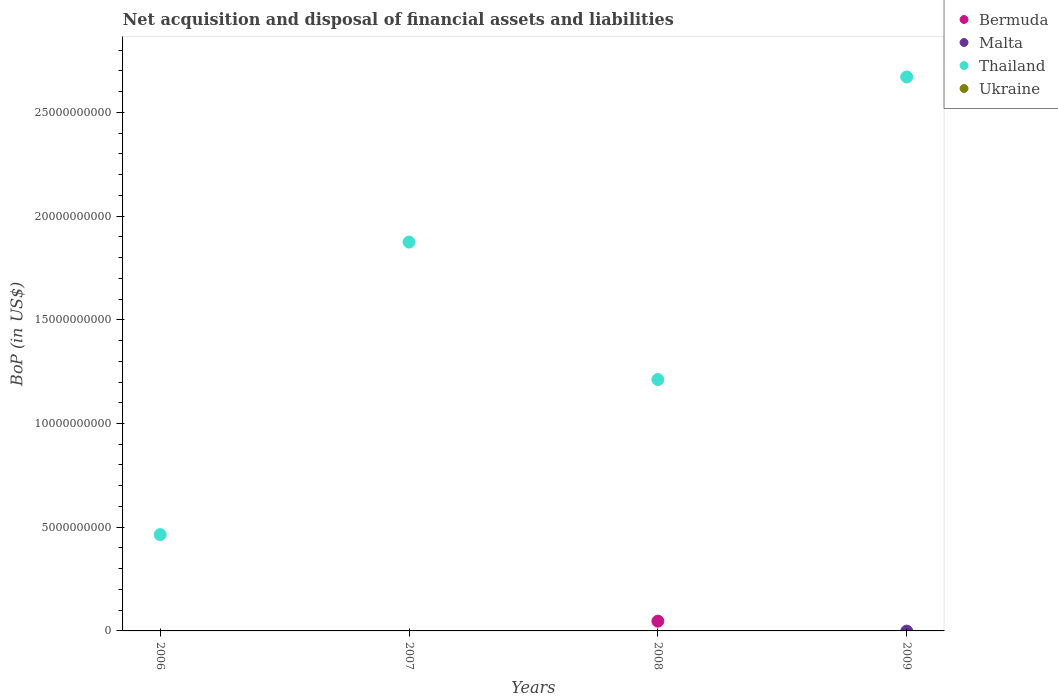How many different coloured dotlines are there?
Give a very brief answer. 2. What is the Balance of Payments in Ukraine in 2007?
Offer a very short reply. 0. Across all years, what is the maximum Balance of Payments in Bermuda?
Your response must be concise. 4.69e+08. Across all years, what is the minimum Balance of Payments in Ukraine?
Keep it short and to the point. 0. In which year was the Balance of Payments in Thailand maximum?
Provide a succinct answer. 2009. What is the difference between the Balance of Payments in Thailand in 2006 and that in 2009?
Your response must be concise. -2.21e+1. What is the difference between the Balance of Payments in Ukraine in 2006 and the Balance of Payments in Bermuda in 2008?
Your answer should be compact. -4.69e+08. In how many years, is the Balance of Payments in Ukraine greater than 21000000000 US$?
Provide a short and direct response. 0. What is the difference between the highest and the lowest Balance of Payments in Bermuda?
Keep it short and to the point. 4.69e+08. Is the sum of the Balance of Payments in Thailand in 2008 and 2009 greater than the maximum Balance of Payments in Malta across all years?
Your answer should be compact. Yes. Is it the case that in every year, the sum of the Balance of Payments in Thailand and Balance of Payments in Bermuda  is greater than the sum of Balance of Payments in Malta and Balance of Payments in Ukraine?
Provide a succinct answer. No. Is it the case that in every year, the sum of the Balance of Payments in Thailand and Balance of Payments in Ukraine  is greater than the Balance of Payments in Malta?
Offer a very short reply. Yes. Does the Balance of Payments in Malta monotonically increase over the years?
Offer a terse response. No. Is the Balance of Payments in Thailand strictly less than the Balance of Payments in Malta over the years?
Provide a short and direct response. No. How many years are there in the graph?
Offer a very short reply. 4. What is the difference between two consecutive major ticks on the Y-axis?
Offer a terse response. 5.00e+09. Are the values on the major ticks of Y-axis written in scientific E-notation?
Provide a short and direct response. No. Does the graph contain grids?
Provide a short and direct response. No. How are the legend labels stacked?
Offer a terse response. Vertical. What is the title of the graph?
Give a very brief answer. Net acquisition and disposal of financial assets and liabilities. What is the label or title of the Y-axis?
Give a very brief answer. BoP (in US$). What is the BoP (in US$) in Bermuda in 2006?
Make the answer very short. 0. What is the BoP (in US$) in Malta in 2006?
Your answer should be very brief. 0. What is the BoP (in US$) of Thailand in 2006?
Offer a terse response. 4.64e+09. What is the BoP (in US$) of Thailand in 2007?
Your answer should be very brief. 1.87e+1. What is the BoP (in US$) in Bermuda in 2008?
Make the answer very short. 4.69e+08. What is the BoP (in US$) of Thailand in 2008?
Your answer should be very brief. 1.21e+1. What is the BoP (in US$) of Malta in 2009?
Give a very brief answer. 0. What is the BoP (in US$) of Thailand in 2009?
Ensure brevity in your answer.  2.67e+1. Across all years, what is the maximum BoP (in US$) of Bermuda?
Offer a terse response. 4.69e+08. Across all years, what is the maximum BoP (in US$) in Thailand?
Keep it short and to the point. 2.67e+1. Across all years, what is the minimum BoP (in US$) of Bermuda?
Provide a short and direct response. 0. Across all years, what is the minimum BoP (in US$) of Thailand?
Keep it short and to the point. 4.64e+09. What is the total BoP (in US$) in Bermuda in the graph?
Provide a succinct answer. 4.69e+08. What is the total BoP (in US$) of Malta in the graph?
Provide a short and direct response. 0. What is the total BoP (in US$) of Thailand in the graph?
Ensure brevity in your answer.  6.22e+1. What is the total BoP (in US$) of Ukraine in the graph?
Provide a short and direct response. 0. What is the difference between the BoP (in US$) in Thailand in 2006 and that in 2007?
Give a very brief answer. -1.41e+1. What is the difference between the BoP (in US$) of Thailand in 2006 and that in 2008?
Your answer should be compact. -7.48e+09. What is the difference between the BoP (in US$) of Thailand in 2006 and that in 2009?
Keep it short and to the point. -2.21e+1. What is the difference between the BoP (in US$) in Thailand in 2007 and that in 2008?
Your answer should be very brief. 6.63e+09. What is the difference between the BoP (in US$) of Thailand in 2007 and that in 2009?
Ensure brevity in your answer.  -7.96e+09. What is the difference between the BoP (in US$) in Thailand in 2008 and that in 2009?
Keep it short and to the point. -1.46e+1. What is the difference between the BoP (in US$) in Bermuda in 2008 and the BoP (in US$) in Thailand in 2009?
Provide a succinct answer. -2.62e+1. What is the average BoP (in US$) in Bermuda per year?
Your answer should be very brief. 1.17e+08. What is the average BoP (in US$) in Malta per year?
Your response must be concise. 0. What is the average BoP (in US$) of Thailand per year?
Your response must be concise. 1.56e+1. In the year 2008, what is the difference between the BoP (in US$) of Bermuda and BoP (in US$) of Thailand?
Ensure brevity in your answer.  -1.17e+1. What is the ratio of the BoP (in US$) of Thailand in 2006 to that in 2007?
Provide a succinct answer. 0.25. What is the ratio of the BoP (in US$) in Thailand in 2006 to that in 2008?
Provide a short and direct response. 0.38. What is the ratio of the BoP (in US$) in Thailand in 2006 to that in 2009?
Make the answer very short. 0.17. What is the ratio of the BoP (in US$) of Thailand in 2007 to that in 2008?
Your response must be concise. 1.55. What is the ratio of the BoP (in US$) in Thailand in 2007 to that in 2009?
Offer a very short reply. 0.7. What is the ratio of the BoP (in US$) of Thailand in 2008 to that in 2009?
Provide a short and direct response. 0.45. What is the difference between the highest and the second highest BoP (in US$) in Thailand?
Make the answer very short. 7.96e+09. What is the difference between the highest and the lowest BoP (in US$) in Bermuda?
Offer a terse response. 4.69e+08. What is the difference between the highest and the lowest BoP (in US$) of Thailand?
Give a very brief answer. 2.21e+1. 